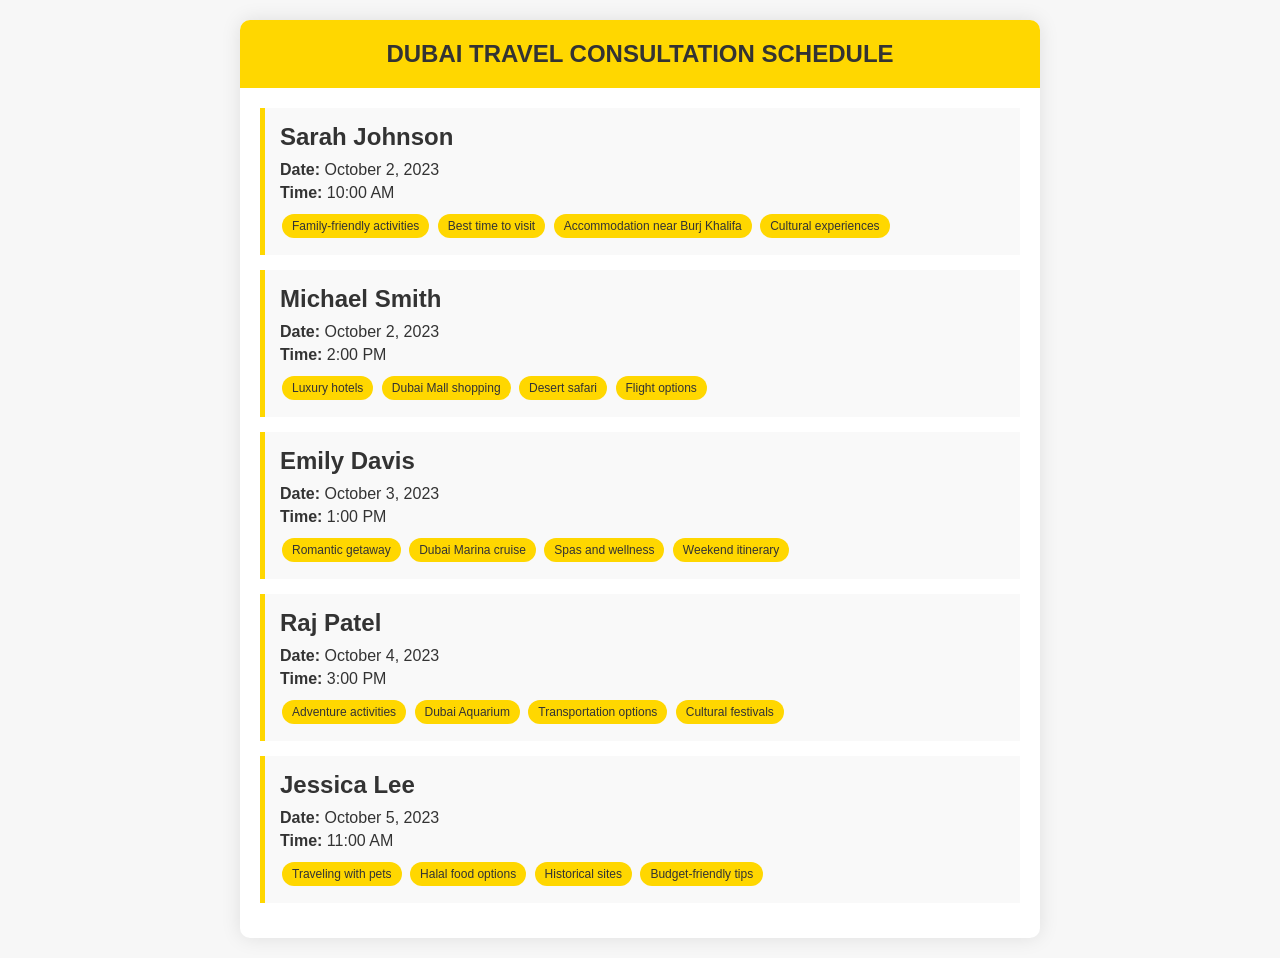What is the date of Sarah Johnson's appointment? The date for Sarah Johnson's appointment is explicitly stated in the document.
Answer: October 2, 2023 What time is Michael Smith's appointment? The time for Michael Smith's appointment is mentioned in the schedule section of the document.
Answer: 2:00 PM What topics will be discussed during Emily Davis's meeting? The topics for Emily Davis's appointment are listed underneath her name in the document.
Answer: Romantic getaway, Dubai Marina cruise, Spas and wellness, Weekend itinerary How many clients have appointments on October 2, 2023? The number of clients is determined by counting the appointments listed for that specific date.
Answer: 2 Which client is interested in adventure activities? The client interested in adventure activities is mentioned along with the topics for their appointment.
Answer: Raj Patel What is the common theme among the topics for Jessica Lee’s appointment? The common theme for Jessica Lee's topics can be derived from the listed topics related to traveling with pets and food options.
Answer: Traveling with pets What is the earliest appointment date listed? The earliest appointment date is found by looking at the dates listed for all clients.
Answer: October 2, 2023 What specific activity did Raj Patel mention in his topics? The specific activity mentioned by Raj Patel is included in his scheduled topics.
Answer: Dubai Aquarium 